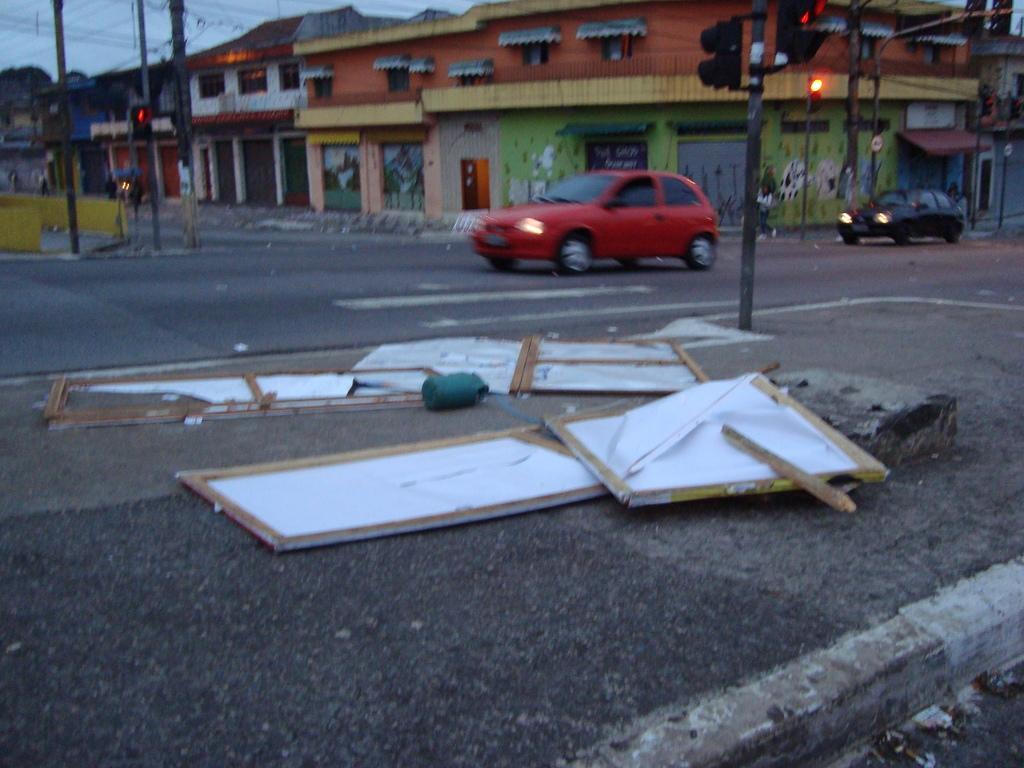Can you describe this image briefly? In this image we can see a few people, there are cars on the road, there are light poles, traffic lights, there are boards on the ground, also we can see houses and the sky. 